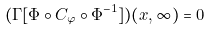Convert formula to latex. <formula><loc_0><loc_0><loc_500><loc_500>( \Gamma [ \Phi \circ C _ { \varphi } \circ \Phi ^ { - 1 } ] ) ( x , \infty ) = 0</formula> 